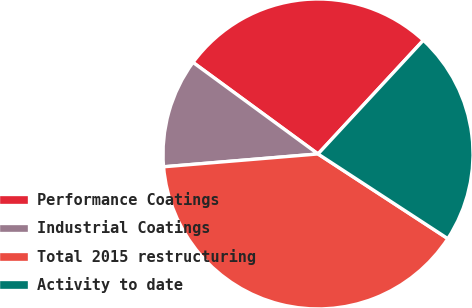Convert chart to OTSL. <chart><loc_0><loc_0><loc_500><loc_500><pie_chart><fcel>Performance Coatings<fcel>Industrial Coatings<fcel>Total 2015 restructuring<fcel>Activity to date<nl><fcel>26.83%<fcel>11.38%<fcel>39.48%<fcel>22.31%<nl></chart> 